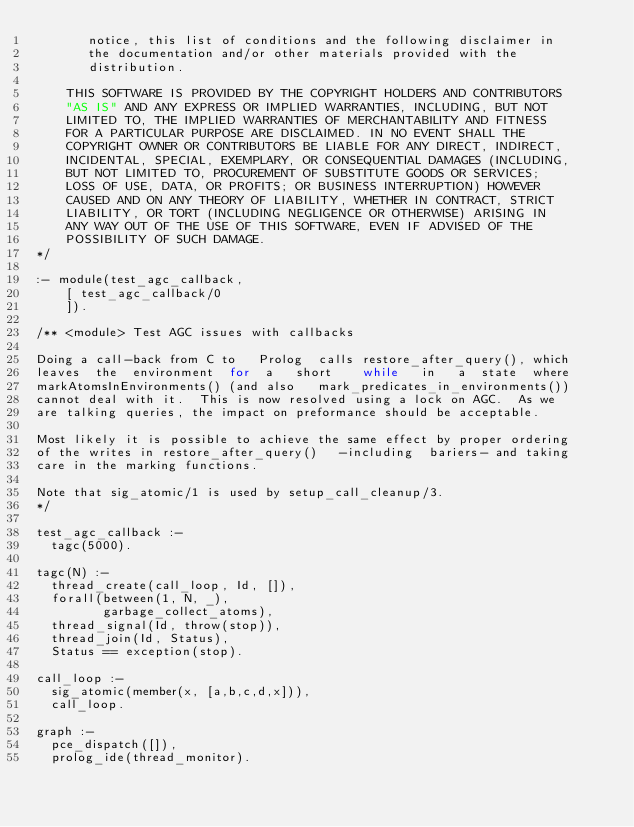Convert code to text. <code><loc_0><loc_0><loc_500><loc_500><_Perl_>       notice, this list of conditions and the following disclaimer in
       the documentation and/or other materials provided with the
       distribution.

    THIS SOFTWARE IS PROVIDED BY THE COPYRIGHT HOLDERS AND CONTRIBUTORS
    "AS IS" AND ANY EXPRESS OR IMPLIED WARRANTIES, INCLUDING, BUT NOT
    LIMITED TO, THE IMPLIED WARRANTIES OF MERCHANTABILITY AND FITNESS
    FOR A PARTICULAR PURPOSE ARE DISCLAIMED. IN NO EVENT SHALL THE
    COPYRIGHT OWNER OR CONTRIBUTORS BE LIABLE FOR ANY DIRECT, INDIRECT,
    INCIDENTAL, SPECIAL, EXEMPLARY, OR CONSEQUENTIAL DAMAGES (INCLUDING,
    BUT NOT LIMITED TO, PROCUREMENT OF SUBSTITUTE GOODS OR SERVICES;
    LOSS OF USE, DATA, OR PROFITS; OR BUSINESS INTERRUPTION) HOWEVER
    CAUSED AND ON ANY THEORY OF LIABILITY, WHETHER IN CONTRACT, STRICT
    LIABILITY, OR TORT (INCLUDING NEGLIGENCE OR OTHERWISE) ARISING IN
    ANY WAY OUT OF THE USE OF THIS SOFTWARE, EVEN IF ADVISED OF THE
    POSSIBILITY OF SUCH DAMAGE.
*/

:- module(test_agc_callback,
	  [ test_agc_callback/0
	  ]).

/** <module> Test AGC issues with callbacks

Doing a call-back from C to   Prolog  calls restore_after_query(), which
leaves  the  environment  for  a   short    while   in   a  state  where
markAtomsInEnvironments() (and also   mark_predicates_in_environments())
cannot deal with it.  This is now resolved using a lock on AGC.  As we
are talking queries, the impact on preformance should be acceptable.

Most likely it is possible to achieve the same effect by proper ordering
of the writes in restore_after_query()   -including  bariers- and taking
care in the marking functions.

Note that sig_atomic/1 is used by setup_call_cleanup/3.
*/

test_agc_callback :-
	tagc(5000).

tagc(N) :-
	thread_create(call_loop, Id, []),
	forall(between(1, N, _),
	       garbage_collect_atoms),
	thread_signal(Id, throw(stop)),
	thread_join(Id, Status),
	Status == exception(stop).

call_loop :-
	sig_atomic(member(x, [a,b,c,d,x])),
	call_loop.

graph :-
	pce_dispatch([]),
	prolog_ide(thread_monitor).
</code> 